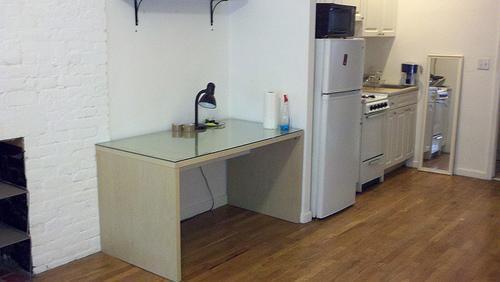How many mirrors are shown?
Give a very brief answer. 1. 